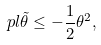Convert formula to latex. <formula><loc_0><loc_0><loc_500><loc_500>\ p l \tilde { \theta } \leq - \frac { 1 } { 2 } { \theta } ^ { 2 } ,</formula> 